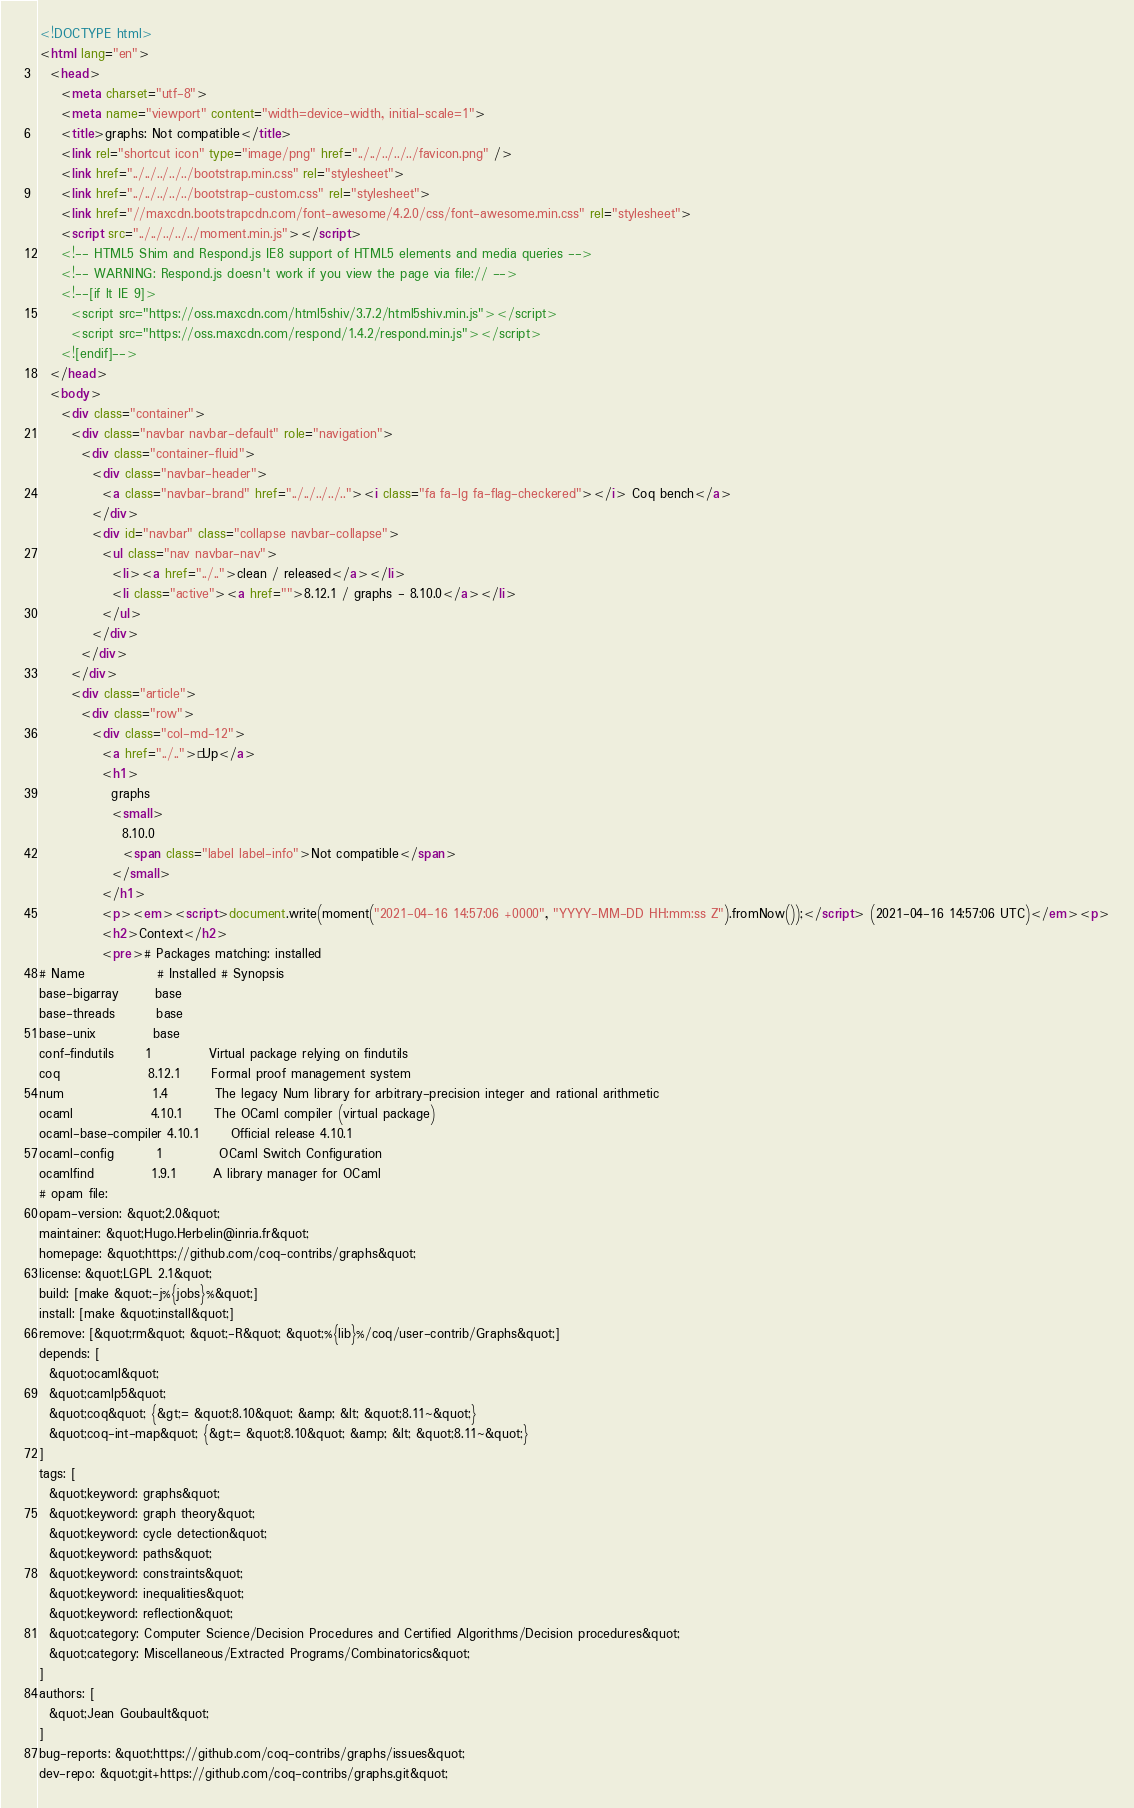Convert code to text. <code><loc_0><loc_0><loc_500><loc_500><_HTML_><!DOCTYPE html>
<html lang="en">
  <head>
    <meta charset="utf-8">
    <meta name="viewport" content="width=device-width, initial-scale=1">
    <title>graphs: Not compatible</title>
    <link rel="shortcut icon" type="image/png" href="../../../../../favicon.png" />
    <link href="../../../../../bootstrap.min.css" rel="stylesheet">
    <link href="../../../../../bootstrap-custom.css" rel="stylesheet">
    <link href="//maxcdn.bootstrapcdn.com/font-awesome/4.2.0/css/font-awesome.min.css" rel="stylesheet">
    <script src="../../../../../moment.min.js"></script>
    <!-- HTML5 Shim and Respond.js IE8 support of HTML5 elements and media queries -->
    <!-- WARNING: Respond.js doesn't work if you view the page via file:// -->
    <!--[if lt IE 9]>
      <script src="https://oss.maxcdn.com/html5shiv/3.7.2/html5shiv.min.js"></script>
      <script src="https://oss.maxcdn.com/respond/1.4.2/respond.min.js"></script>
    <![endif]-->
  </head>
  <body>
    <div class="container">
      <div class="navbar navbar-default" role="navigation">
        <div class="container-fluid">
          <div class="navbar-header">
            <a class="navbar-brand" href="../../../../.."><i class="fa fa-lg fa-flag-checkered"></i> Coq bench</a>
          </div>
          <div id="navbar" class="collapse navbar-collapse">
            <ul class="nav navbar-nav">
              <li><a href="../..">clean / released</a></li>
              <li class="active"><a href="">8.12.1 / graphs - 8.10.0</a></li>
            </ul>
          </div>
        </div>
      </div>
      <div class="article">
        <div class="row">
          <div class="col-md-12">
            <a href="../..">« Up</a>
            <h1>
              graphs
              <small>
                8.10.0
                <span class="label label-info">Not compatible</span>
              </small>
            </h1>
            <p><em><script>document.write(moment("2021-04-16 14:57:06 +0000", "YYYY-MM-DD HH:mm:ss Z").fromNow());</script> (2021-04-16 14:57:06 UTC)</em><p>
            <h2>Context</h2>
            <pre># Packages matching: installed
# Name              # Installed # Synopsis
base-bigarray       base
base-threads        base
base-unix           base
conf-findutils      1           Virtual package relying on findutils
coq                 8.12.1      Formal proof management system
num                 1.4         The legacy Num library for arbitrary-precision integer and rational arithmetic
ocaml               4.10.1      The OCaml compiler (virtual package)
ocaml-base-compiler 4.10.1      Official release 4.10.1
ocaml-config        1           OCaml Switch Configuration
ocamlfind           1.9.1       A library manager for OCaml
# opam file:
opam-version: &quot;2.0&quot;
maintainer: &quot;Hugo.Herbelin@inria.fr&quot;
homepage: &quot;https://github.com/coq-contribs/graphs&quot;
license: &quot;LGPL 2.1&quot;
build: [make &quot;-j%{jobs}%&quot;]
install: [make &quot;install&quot;]
remove: [&quot;rm&quot; &quot;-R&quot; &quot;%{lib}%/coq/user-contrib/Graphs&quot;]
depends: [
  &quot;ocaml&quot;
  &quot;camlp5&quot;
  &quot;coq&quot; {&gt;= &quot;8.10&quot; &amp; &lt; &quot;8.11~&quot;}
  &quot;coq-int-map&quot; {&gt;= &quot;8.10&quot; &amp; &lt; &quot;8.11~&quot;}
]
tags: [
  &quot;keyword: graphs&quot;
  &quot;keyword: graph theory&quot;
  &quot;keyword: cycle detection&quot;
  &quot;keyword: paths&quot;
  &quot;keyword: constraints&quot;
  &quot;keyword: inequalities&quot;
  &quot;keyword: reflection&quot;
  &quot;category: Computer Science/Decision Procedures and Certified Algorithms/Decision procedures&quot;
  &quot;category: Miscellaneous/Extracted Programs/Combinatorics&quot;
]
authors: [
  &quot;Jean Goubault&quot;
]
bug-reports: &quot;https://github.com/coq-contribs/graphs/issues&quot;
dev-repo: &quot;git+https://github.com/coq-contribs/graphs.git&quot;</code> 